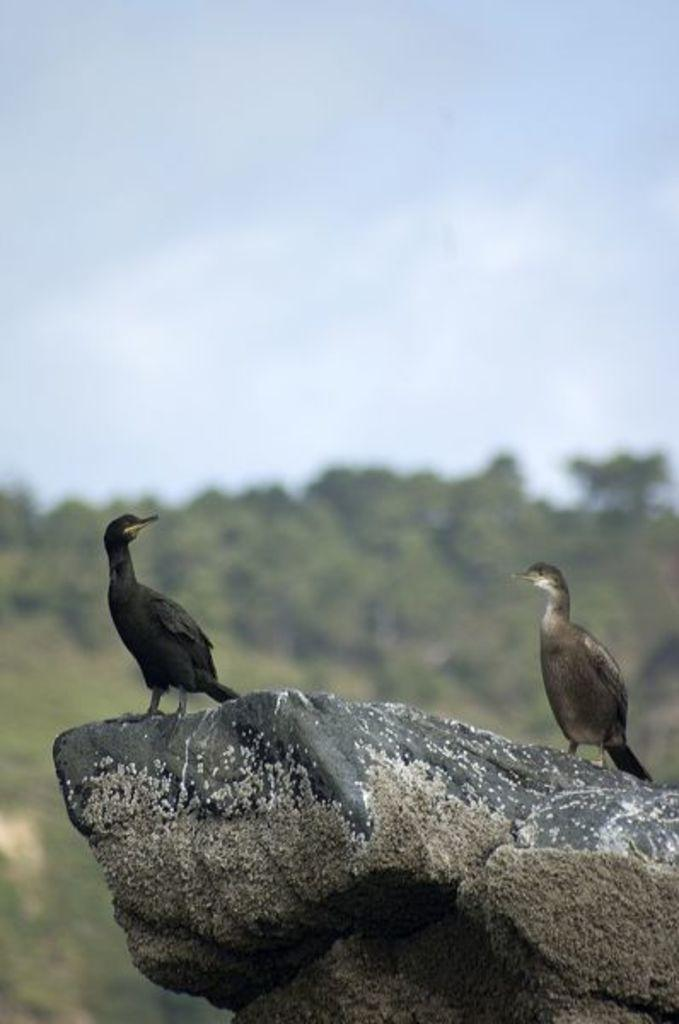What is the main subject in the center of the image? There is a stone in the center of the image. What is on top of the stone? There are two birds on the stone. What can be said about the color of the birds? The birds are in black and white color. What is visible in the background of the image? There is sky, clouds, and trees visible in the background of the image. What type of learning material is the cub using in the image? There is no cub or learning material present in the image. 